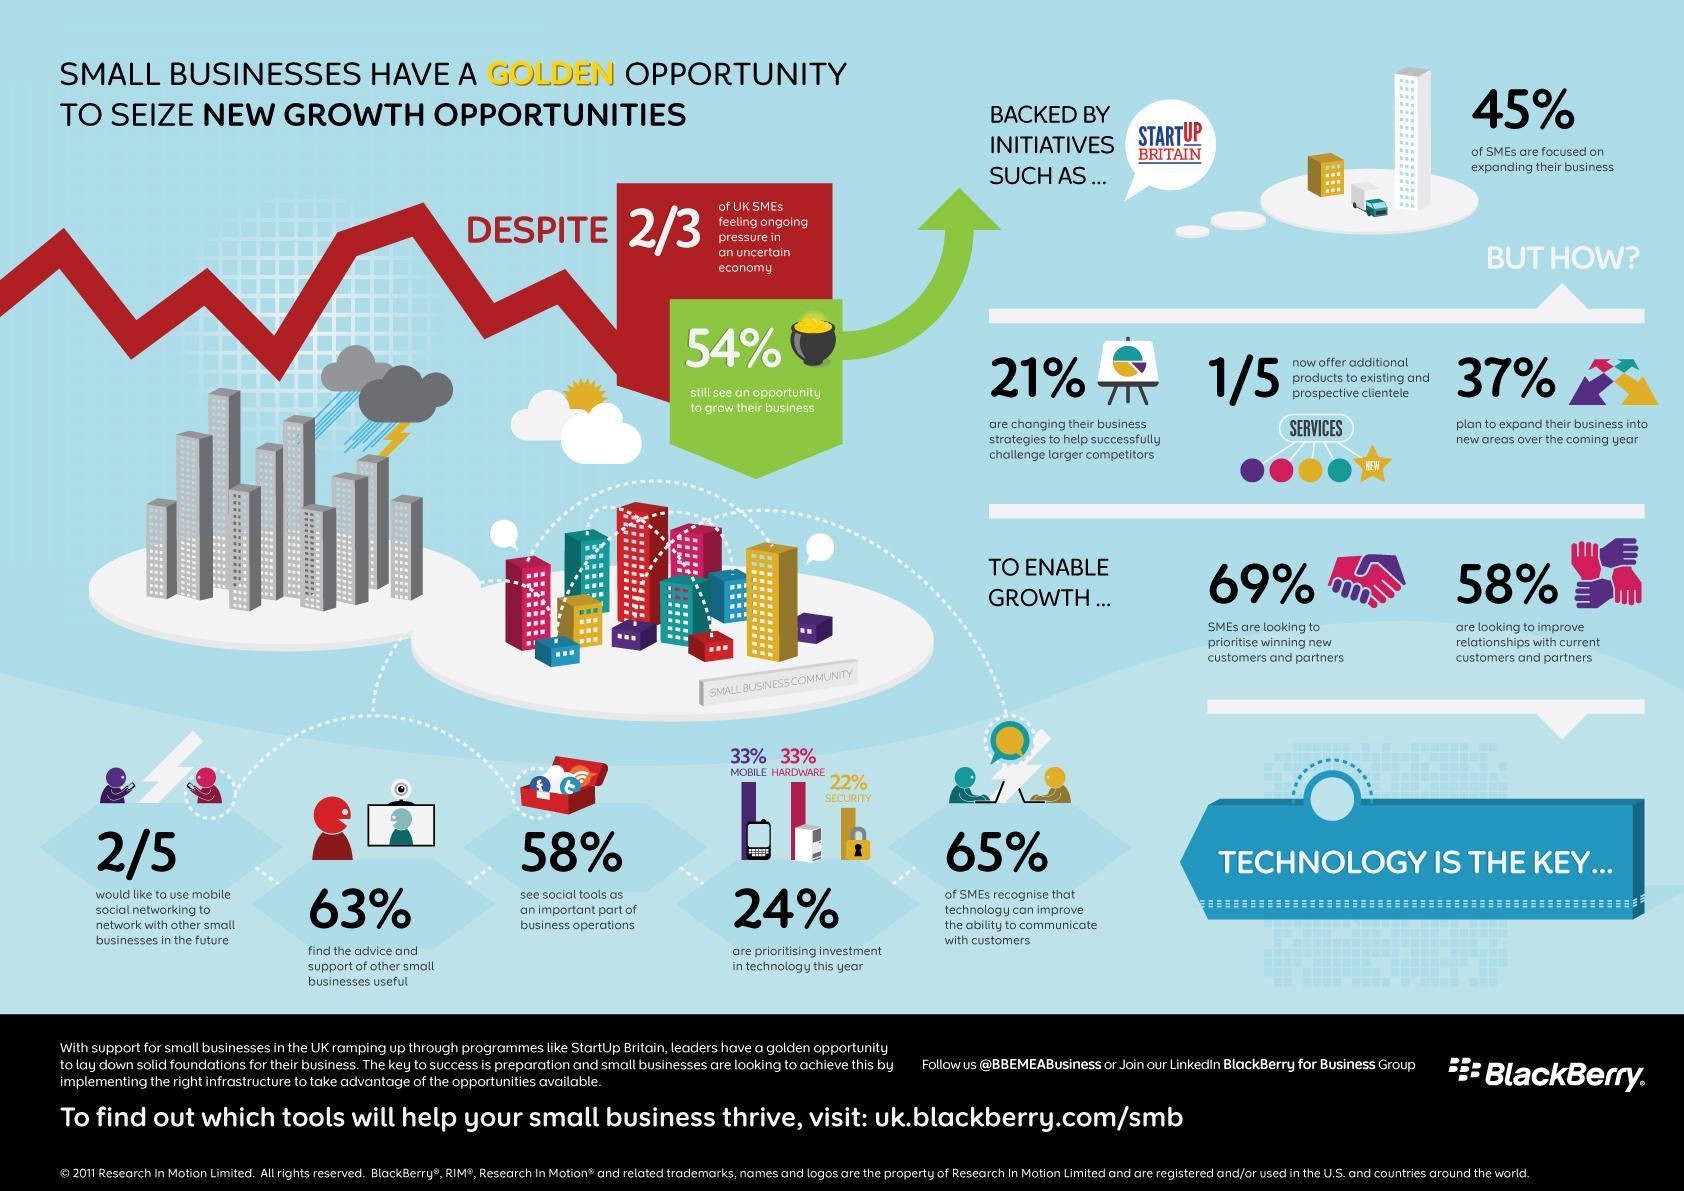What percentage of UK SMEs are looking to improve relationships with current customers & partners?
Answer the question with a short phrase. 58% What percentage of UK SMEs are not focussed on expanding their business? 55% What percentage of SMEs in UK do not recognise that technology can improve the ability to communicate with customers? 35% What percentage of UK SMEs find the support of other small business useful? 63% What percentage of SMEs are prioritising investment in Hardware technologies this year in UK? 33% What percentage of UK SMEs do not consider social tools as an important part of business operations? 42% 